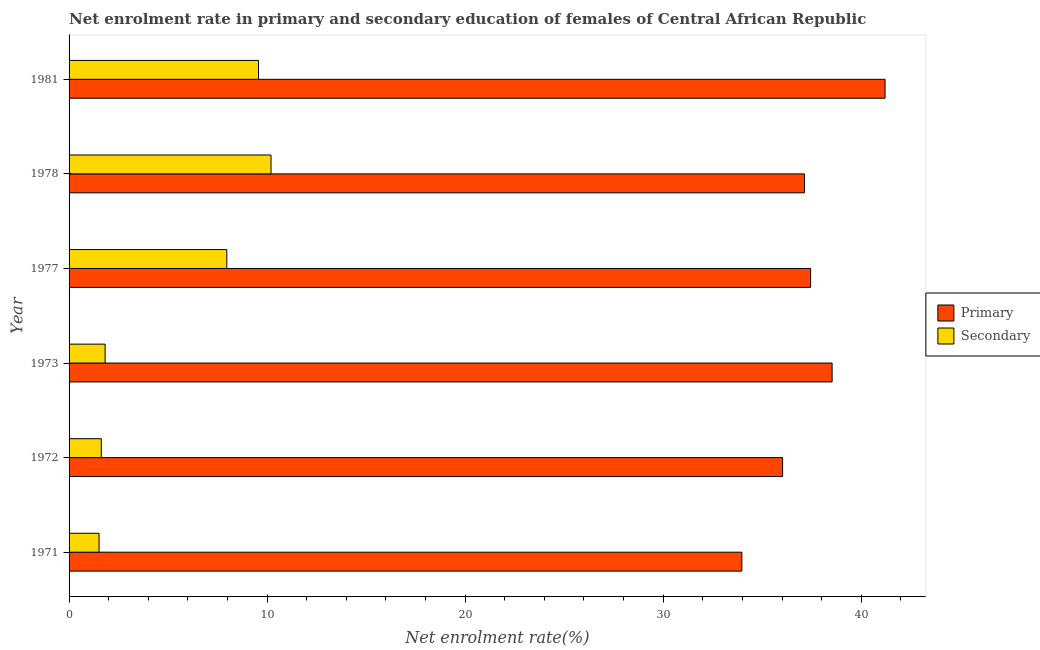Are the number of bars per tick equal to the number of legend labels?
Make the answer very short. Yes. How many bars are there on the 3rd tick from the top?
Keep it short and to the point. 2. What is the label of the 3rd group of bars from the top?
Provide a short and direct response. 1977. In how many cases, is the number of bars for a given year not equal to the number of legend labels?
Provide a succinct answer. 0. What is the enrollment rate in secondary education in 1978?
Give a very brief answer. 10.2. Across all years, what is the maximum enrollment rate in secondary education?
Keep it short and to the point. 10.2. Across all years, what is the minimum enrollment rate in secondary education?
Ensure brevity in your answer.  1.51. In which year was the enrollment rate in secondary education maximum?
Provide a short and direct response. 1978. In which year was the enrollment rate in primary education minimum?
Your answer should be very brief. 1971. What is the total enrollment rate in secondary education in the graph?
Your answer should be very brief. 32.69. What is the difference between the enrollment rate in secondary education in 1971 and that in 1972?
Make the answer very short. -0.11. What is the difference between the enrollment rate in primary education in 1973 and the enrollment rate in secondary education in 1981?
Provide a succinct answer. 28.96. What is the average enrollment rate in secondary education per year?
Give a very brief answer. 5.45. In the year 1973, what is the difference between the enrollment rate in primary education and enrollment rate in secondary education?
Ensure brevity in your answer.  36.71. In how many years, is the enrollment rate in primary education greater than 2 %?
Ensure brevity in your answer.  6. What is the ratio of the enrollment rate in secondary education in 1973 to that in 1978?
Ensure brevity in your answer.  0.18. Is the enrollment rate in primary education in 1972 less than that in 1981?
Provide a succinct answer. Yes. Is the difference between the enrollment rate in primary education in 1978 and 1981 greater than the difference between the enrollment rate in secondary education in 1978 and 1981?
Offer a very short reply. No. What is the difference between the highest and the second highest enrollment rate in primary education?
Make the answer very short. 2.67. What is the difference between the highest and the lowest enrollment rate in secondary education?
Your answer should be compact. 8.68. In how many years, is the enrollment rate in secondary education greater than the average enrollment rate in secondary education taken over all years?
Ensure brevity in your answer.  3. Is the sum of the enrollment rate in secondary education in 1972 and 1978 greater than the maximum enrollment rate in primary education across all years?
Your response must be concise. No. What does the 2nd bar from the top in 1972 represents?
Provide a succinct answer. Primary. What does the 2nd bar from the bottom in 1978 represents?
Your response must be concise. Secondary. Are all the bars in the graph horizontal?
Keep it short and to the point. Yes. How many years are there in the graph?
Ensure brevity in your answer.  6. Does the graph contain any zero values?
Offer a terse response. No. Where does the legend appear in the graph?
Offer a terse response. Center right. How many legend labels are there?
Ensure brevity in your answer.  2. How are the legend labels stacked?
Offer a very short reply. Vertical. What is the title of the graph?
Ensure brevity in your answer.  Net enrolment rate in primary and secondary education of females of Central African Republic. What is the label or title of the X-axis?
Provide a succinct answer. Net enrolment rate(%). What is the Net enrolment rate(%) of Primary in 1971?
Offer a very short reply. 33.97. What is the Net enrolment rate(%) of Secondary in 1971?
Provide a short and direct response. 1.51. What is the Net enrolment rate(%) of Primary in 1972?
Keep it short and to the point. 36.03. What is the Net enrolment rate(%) of Secondary in 1972?
Provide a succinct answer. 1.63. What is the Net enrolment rate(%) of Primary in 1973?
Your response must be concise. 38.53. What is the Net enrolment rate(%) of Secondary in 1973?
Give a very brief answer. 1.82. What is the Net enrolment rate(%) in Primary in 1977?
Offer a terse response. 37.44. What is the Net enrolment rate(%) of Secondary in 1977?
Provide a short and direct response. 7.96. What is the Net enrolment rate(%) of Primary in 1978?
Provide a succinct answer. 37.13. What is the Net enrolment rate(%) in Secondary in 1978?
Your answer should be compact. 10.2. What is the Net enrolment rate(%) of Primary in 1981?
Your answer should be very brief. 41.2. What is the Net enrolment rate(%) of Secondary in 1981?
Provide a short and direct response. 9.57. Across all years, what is the maximum Net enrolment rate(%) in Primary?
Your response must be concise. 41.2. Across all years, what is the maximum Net enrolment rate(%) in Secondary?
Offer a very short reply. 10.2. Across all years, what is the minimum Net enrolment rate(%) of Primary?
Make the answer very short. 33.97. Across all years, what is the minimum Net enrolment rate(%) of Secondary?
Give a very brief answer. 1.51. What is the total Net enrolment rate(%) in Primary in the graph?
Give a very brief answer. 224.31. What is the total Net enrolment rate(%) of Secondary in the graph?
Your answer should be compact. 32.69. What is the difference between the Net enrolment rate(%) in Primary in 1971 and that in 1972?
Keep it short and to the point. -2.06. What is the difference between the Net enrolment rate(%) in Secondary in 1971 and that in 1972?
Keep it short and to the point. -0.11. What is the difference between the Net enrolment rate(%) of Primary in 1971 and that in 1973?
Give a very brief answer. -4.56. What is the difference between the Net enrolment rate(%) in Secondary in 1971 and that in 1973?
Offer a terse response. -0.31. What is the difference between the Net enrolment rate(%) in Primary in 1971 and that in 1977?
Ensure brevity in your answer.  -3.47. What is the difference between the Net enrolment rate(%) of Secondary in 1971 and that in 1977?
Offer a very short reply. -6.45. What is the difference between the Net enrolment rate(%) of Primary in 1971 and that in 1978?
Make the answer very short. -3.16. What is the difference between the Net enrolment rate(%) of Secondary in 1971 and that in 1978?
Your response must be concise. -8.68. What is the difference between the Net enrolment rate(%) of Primary in 1971 and that in 1981?
Provide a succinct answer. -7.23. What is the difference between the Net enrolment rate(%) in Secondary in 1971 and that in 1981?
Offer a very short reply. -8.05. What is the difference between the Net enrolment rate(%) in Primary in 1972 and that in 1973?
Your answer should be very brief. -2.5. What is the difference between the Net enrolment rate(%) in Secondary in 1972 and that in 1973?
Provide a succinct answer. -0.19. What is the difference between the Net enrolment rate(%) in Primary in 1972 and that in 1977?
Your answer should be compact. -1.42. What is the difference between the Net enrolment rate(%) of Secondary in 1972 and that in 1977?
Make the answer very short. -6.34. What is the difference between the Net enrolment rate(%) in Primary in 1972 and that in 1978?
Offer a terse response. -1.1. What is the difference between the Net enrolment rate(%) of Secondary in 1972 and that in 1978?
Offer a terse response. -8.57. What is the difference between the Net enrolment rate(%) of Primary in 1972 and that in 1981?
Offer a terse response. -5.17. What is the difference between the Net enrolment rate(%) of Secondary in 1972 and that in 1981?
Offer a terse response. -7.94. What is the difference between the Net enrolment rate(%) in Primary in 1973 and that in 1977?
Your response must be concise. 1.08. What is the difference between the Net enrolment rate(%) in Secondary in 1973 and that in 1977?
Keep it short and to the point. -6.14. What is the difference between the Net enrolment rate(%) of Primary in 1973 and that in 1978?
Your answer should be compact. 1.4. What is the difference between the Net enrolment rate(%) in Secondary in 1973 and that in 1978?
Your answer should be compact. -8.38. What is the difference between the Net enrolment rate(%) in Primary in 1973 and that in 1981?
Your response must be concise. -2.67. What is the difference between the Net enrolment rate(%) of Secondary in 1973 and that in 1981?
Offer a terse response. -7.75. What is the difference between the Net enrolment rate(%) in Primary in 1977 and that in 1978?
Your answer should be very brief. 0.31. What is the difference between the Net enrolment rate(%) of Secondary in 1977 and that in 1978?
Your response must be concise. -2.23. What is the difference between the Net enrolment rate(%) of Primary in 1977 and that in 1981?
Offer a terse response. -3.76. What is the difference between the Net enrolment rate(%) of Secondary in 1977 and that in 1981?
Provide a succinct answer. -1.6. What is the difference between the Net enrolment rate(%) in Primary in 1978 and that in 1981?
Offer a terse response. -4.07. What is the difference between the Net enrolment rate(%) of Secondary in 1978 and that in 1981?
Offer a terse response. 0.63. What is the difference between the Net enrolment rate(%) in Primary in 1971 and the Net enrolment rate(%) in Secondary in 1972?
Keep it short and to the point. 32.34. What is the difference between the Net enrolment rate(%) of Primary in 1971 and the Net enrolment rate(%) of Secondary in 1973?
Provide a succinct answer. 32.15. What is the difference between the Net enrolment rate(%) in Primary in 1971 and the Net enrolment rate(%) in Secondary in 1977?
Give a very brief answer. 26.01. What is the difference between the Net enrolment rate(%) of Primary in 1971 and the Net enrolment rate(%) of Secondary in 1978?
Offer a very short reply. 23.77. What is the difference between the Net enrolment rate(%) in Primary in 1971 and the Net enrolment rate(%) in Secondary in 1981?
Your answer should be very brief. 24.41. What is the difference between the Net enrolment rate(%) of Primary in 1972 and the Net enrolment rate(%) of Secondary in 1973?
Ensure brevity in your answer.  34.21. What is the difference between the Net enrolment rate(%) in Primary in 1972 and the Net enrolment rate(%) in Secondary in 1977?
Your response must be concise. 28.06. What is the difference between the Net enrolment rate(%) in Primary in 1972 and the Net enrolment rate(%) in Secondary in 1978?
Your response must be concise. 25.83. What is the difference between the Net enrolment rate(%) in Primary in 1972 and the Net enrolment rate(%) in Secondary in 1981?
Provide a succinct answer. 26.46. What is the difference between the Net enrolment rate(%) in Primary in 1973 and the Net enrolment rate(%) in Secondary in 1977?
Your response must be concise. 30.56. What is the difference between the Net enrolment rate(%) in Primary in 1973 and the Net enrolment rate(%) in Secondary in 1978?
Your answer should be very brief. 28.33. What is the difference between the Net enrolment rate(%) in Primary in 1973 and the Net enrolment rate(%) in Secondary in 1981?
Your answer should be compact. 28.96. What is the difference between the Net enrolment rate(%) of Primary in 1977 and the Net enrolment rate(%) of Secondary in 1978?
Make the answer very short. 27.25. What is the difference between the Net enrolment rate(%) of Primary in 1977 and the Net enrolment rate(%) of Secondary in 1981?
Provide a succinct answer. 27.88. What is the difference between the Net enrolment rate(%) in Primary in 1978 and the Net enrolment rate(%) in Secondary in 1981?
Offer a very short reply. 27.57. What is the average Net enrolment rate(%) in Primary per year?
Give a very brief answer. 37.38. What is the average Net enrolment rate(%) of Secondary per year?
Your answer should be very brief. 5.45. In the year 1971, what is the difference between the Net enrolment rate(%) of Primary and Net enrolment rate(%) of Secondary?
Provide a short and direct response. 32.46. In the year 1972, what is the difference between the Net enrolment rate(%) of Primary and Net enrolment rate(%) of Secondary?
Offer a terse response. 34.4. In the year 1973, what is the difference between the Net enrolment rate(%) in Primary and Net enrolment rate(%) in Secondary?
Your response must be concise. 36.71. In the year 1977, what is the difference between the Net enrolment rate(%) of Primary and Net enrolment rate(%) of Secondary?
Ensure brevity in your answer.  29.48. In the year 1978, what is the difference between the Net enrolment rate(%) in Primary and Net enrolment rate(%) in Secondary?
Your response must be concise. 26.94. In the year 1981, what is the difference between the Net enrolment rate(%) of Primary and Net enrolment rate(%) of Secondary?
Your answer should be compact. 31.64. What is the ratio of the Net enrolment rate(%) of Primary in 1971 to that in 1972?
Ensure brevity in your answer.  0.94. What is the ratio of the Net enrolment rate(%) of Secondary in 1971 to that in 1972?
Ensure brevity in your answer.  0.93. What is the ratio of the Net enrolment rate(%) of Primary in 1971 to that in 1973?
Your answer should be very brief. 0.88. What is the ratio of the Net enrolment rate(%) of Secondary in 1971 to that in 1973?
Provide a short and direct response. 0.83. What is the ratio of the Net enrolment rate(%) of Primary in 1971 to that in 1977?
Your answer should be very brief. 0.91. What is the ratio of the Net enrolment rate(%) of Secondary in 1971 to that in 1977?
Ensure brevity in your answer.  0.19. What is the ratio of the Net enrolment rate(%) in Primary in 1971 to that in 1978?
Your answer should be very brief. 0.91. What is the ratio of the Net enrolment rate(%) of Secondary in 1971 to that in 1978?
Keep it short and to the point. 0.15. What is the ratio of the Net enrolment rate(%) of Primary in 1971 to that in 1981?
Offer a terse response. 0.82. What is the ratio of the Net enrolment rate(%) in Secondary in 1971 to that in 1981?
Provide a short and direct response. 0.16. What is the ratio of the Net enrolment rate(%) in Primary in 1972 to that in 1973?
Offer a terse response. 0.94. What is the ratio of the Net enrolment rate(%) in Secondary in 1972 to that in 1973?
Make the answer very short. 0.89. What is the ratio of the Net enrolment rate(%) of Primary in 1972 to that in 1977?
Your answer should be very brief. 0.96. What is the ratio of the Net enrolment rate(%) in Secondary in 1972 to that in 1977?
Make the answer very short. 0.2. What is the ratio of the Net enrolment rate(%) of Primary in 1972 to that in 1978?
Ensure brevity in your answer.  0.97. What is the ratio of the Net enrolment rate(%) of Secondary in 1972 to that in 1978?
Your answer should be compact. 0.16. What is the ratio of the Net enrolment rate(%) in Primary in 1972 to that in 1981?
Make the answer very short. 0.87. What is the ratio of the Net enrolment rate(%) in Secondary in 1972 to that in 1981?
Your response must be concise. 0.17. What is the ratio of the Net enrolment rate(%) in Secondary in 1973 to that in 1977?
Your answer should be very brief. 0.23. What is the ratio of the Net enrolment rate(%) in Primary in 1973 to that in 1978?
Offer a terse response. 1.04. What is the ratio of the Net enrolment rate(%) of Secondary in 1973 to that in 1978?
Keep it short and to the point. 0.18. What is the ratio of the Net enrolment rate(%) of Primary in 1973 to that in 1981?
Your answer should be compact. 0.94. What is the ratio of the Net enrolment rate(%) of Secondary in 1973 to that in 1981?
Your response must be concise. 0.19. What is the ratio of the Net enrolment rate(%) in Primary in 1977 to that in 1978?
Ensure brevity in your answer.  1.01. What is the ratio of the Net enrolment rate(%) in Secondary in 1977 to that in 1978?
Give a very brief answer. 0.78. What is the ratio of the Net enrolment rate(%) of Primary in 1977 to that in 1981?
Provide a succinct answer. 0.91. What is the ratio of the Net enrolment rate(%) of Secondary in 1977 to that in 1981?
Offer a terse response. 0.83. What is the ratio of the Net enrolment rate(%) in Primary in 1978 to that in 1981?
Offer a very short reply. 0.9. What is the ratio of the Net enrolment rate(%) of Secondary in 1978 to that in 1981?
Make the answer very short. 1.07. What is the difference between the highest and the second highest Net enrolment rate(%) in Primary?
Your answer should be very brief. 2.67. What is the difference between the highest and the second highest Net enrolment rate(%) in Secondary?
Keep it short and to the point. 0.63. What is the difference between the highest and the lowest Net enrolment rate(%) in Primary?
Give a very brief answer. 7.23. What is the difference between the highest and the lowest Net enrolment rate(%) in Secondary?
Provide a short and direct response. 8.68. 